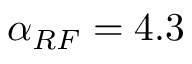Convert formula to latex. <formula><loc_0><loc_0><loc_500><loc_500>\alpha _ { R F } = 4 . 3 \,</formula> 